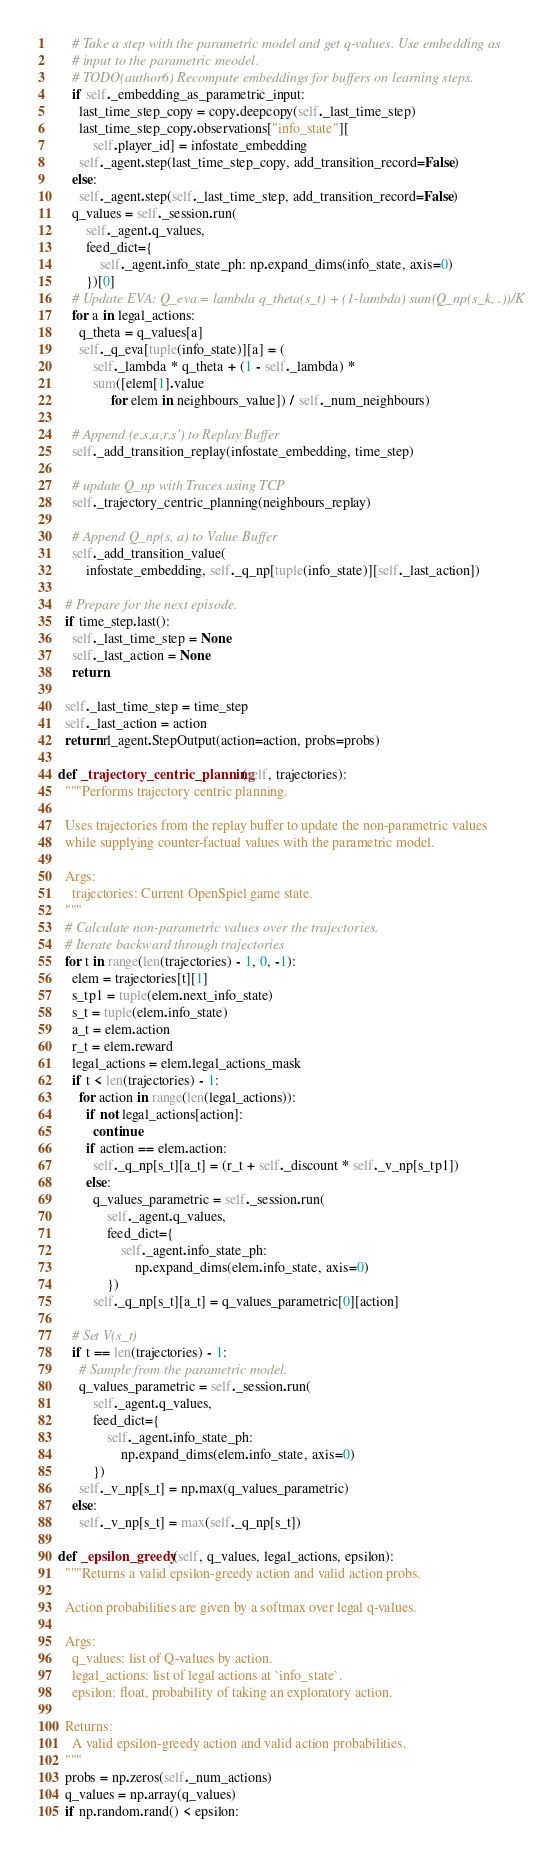<code> <loc_0><loc_0><loc_500><loc_500><_Python_>      # Take a step with the parametric model and get q-values. Use embedding as
      # input to the parametric meodel.
      # TODO(author6) Recompute embeddings for buffers on learning steps.
      if self._embedding_as_parametric_input:
        last_time_step_copy = copy.deepcopy(self._last_time_step)
        last_time_step_copy.observations["info_state"][
            self.player_id] = infostate_embedding
        self._agent.step(last_time_step_copy, add_transition_record=False)
      else:
        self._agent.step(self._last_time_step, add_transition_record=False)
      q_values = self._session.run(
          self._agent.q_values,
          feed_dict={
              self._agent.info_state_ph: np.expand_dims(info_state, axis=0)
          })[0]
      # Update EVA: Q_eva = lambda q_theta(s_t) + (1-lambda) sum(Q_np(s_k, .))/K
      for a in legal_actions:
        q_theta = q_values[a]
        self._q_eva[tuple(info_state)][a] = (
            self._lambda * q_theta + (1 - self._lambda) *
            sum([elem[1].value
                 for elem in neighbours_value]) / self._num_neighbours)

      # Append (e,s,a,r,s') to Replay Buffer
      self._add_transition_replay(infostate_embedding, time_step)

      # update Q_np with Traces using TCP
      self._trajectory_centric_planning(neighbours_replay)

      # Append Q_np(s, a) to Value Buffer
      self._add_transition_value(
          infostate_embedding, self._q_np[tuple(info_state)][self._last_action])

    # Prepare for the next episode.
    if time_step.last():
      self._last_time_step = None
      self._last_action = None
      return

    self._last_time_step = time_step
    self._last_action = action
    return rl_agent.StepOutput(action=action, probs=probs)

  def _trajectory_centric_planning(self, trajectories):
    """Performs trajectory centric planning.

    Uses trajectories from the replay buffer to update the non-parametric values
    while supplying counter-factual values with the parametric model.

    Args:
      trajectories: Current OpenSpiel game state.
    """
    # Calculate non-parametric values over the trajectories.
    # Iterate backward through trajectories
    for t in range(len(trajectories) - 1, 0, -1):
      elem = trajectories[t][1]
      s_tp1 = tuple(elem.next_info_state)
      s_t = tuple(elem.info_state)
      a_t = elem.action
      r_t = elem.reward
      legal_actions = elem.legal_actions_mask
      if t < len(trajectories) - 1:
        for action in range(len(legal_actions)):
          if not legal_actions[action]:
            continue
          if action == elem.action:
            self._q_np[s_t][a_t] = (r_t + self._discount * self._v_np[s_tp1])
          else:
            q_values_parametric = self._session.run(
                self._agent.q_values,
                feed_dict={
                    self._agent.info_state_ph:
                        np.expand_dims(elem.info_state, axis=0)
                })
            self._q_np[s_t][a_t] = q_values_parametric[0][action]

      # Set V(s_t)
      if t == len(trajectories) - 1:
        # Sample from the parametric model.
        q_values_parametric = self._session.run(
            self._agent.q_values,
            feed_dict={
                self._agent.info_state_ph:
                    np.expand_dims(elem.info_state, axis=0)
            })
        self._v_np[s_t] = np.max(q_values_parametric)
      else:
        self._v_np[s_t] = max(self._q_np[s_t])

  def _epsilon_greedy(self, q_values, legal_actions, epsilon):
    """Returns a valid epsilon-greedy action and valid action probs.

    Action probabilities are given by a softmax over legal q-values.

    Args:
      q_values: list of Q-values by action.
      legal_actions: list of legal actions at `info_state`.
      epsilon: float, probability of taking an exploratory action.

    Returns:
      A valid epsilon-greedy action and valid action probabilities.
    """
    probs = np.zeros(self._num_actions)
    q_values = np.array(q_values)
    if np.random.rand() < epsilon:</code> 